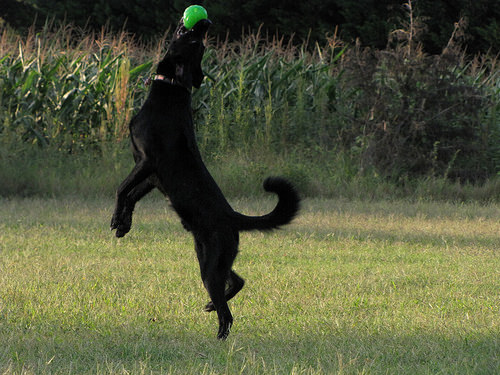<image>
Is the grass under the ball? Yes. The grass is positioned underneath the ball, with the ball above it in the vertical space. Where is the dog in relation to the ball? Is it under the ball? Yes. The dog is positioned underneath the ball, with the ball above it in the vertical space. Is the dog in front of the ball? No. The dog is not in front of the ball. The spatial positioning shows a different relationship between these objects. 